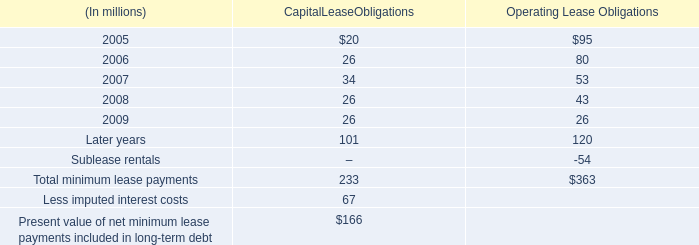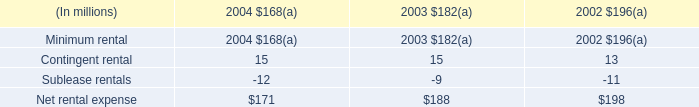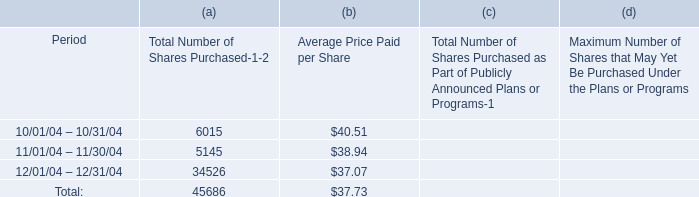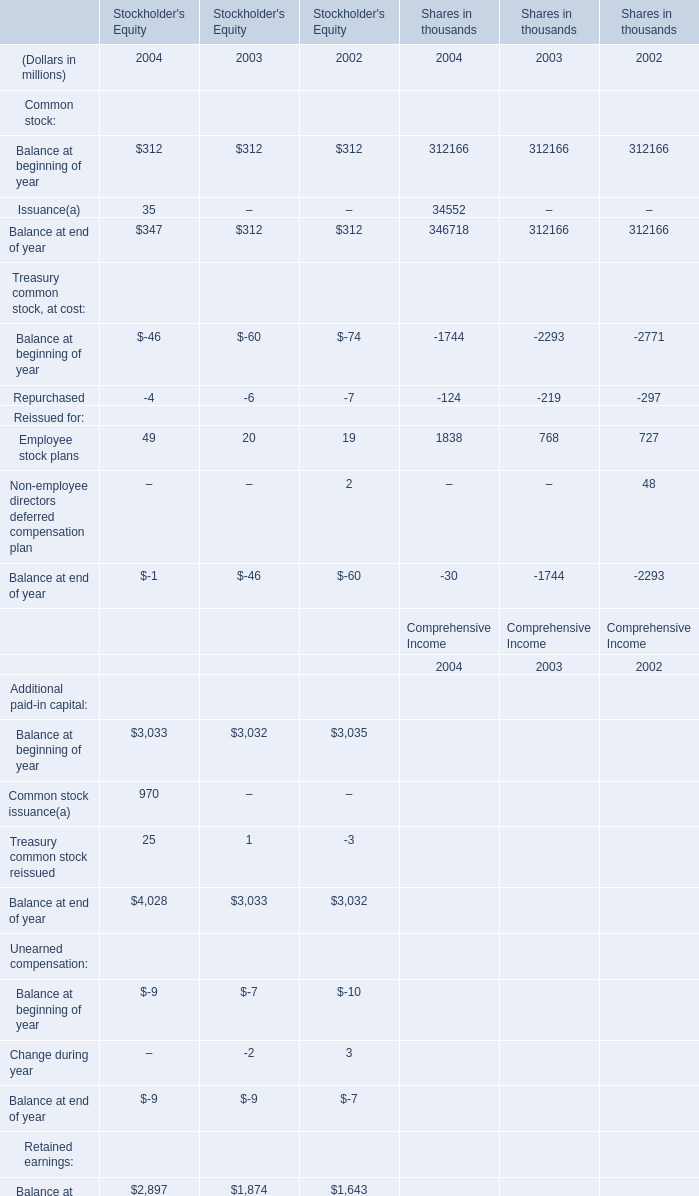If Balance at end of year for for Common stock in Stockholder's Equity develops with the same growth rate in 2004, what will it reach in 2005? (in million) 
Computations: (347 * (1 + ((347 - 312) / 312)))
Answer: 385.92628. 